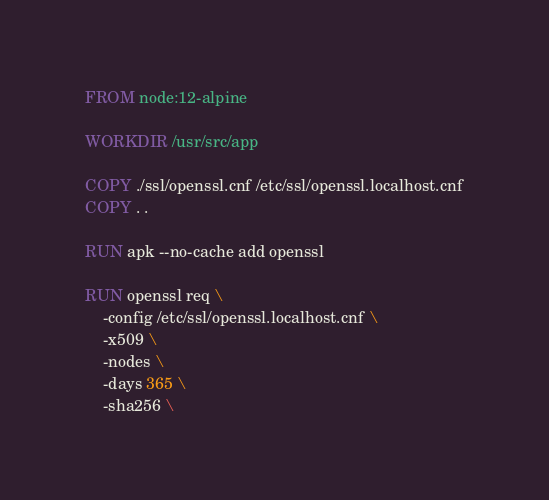Convert code to text. <code><loc_0><loc_0><loc_500><loc_500><_Dockerfile_>FROM node:12-alpine

WORKDIR /usr/src/app

COPY ./ssl/openssl.cnf /etc/ssl/openssl.localhost.cnf
COPY . .

RUN apk --no-cache add openssl

RUN openssl req \
    -config /etc/ssl/openssl.localhost.cnf \
    -x509 \
    -nodes \
    -days 365 \
    -sha256 \</code> 